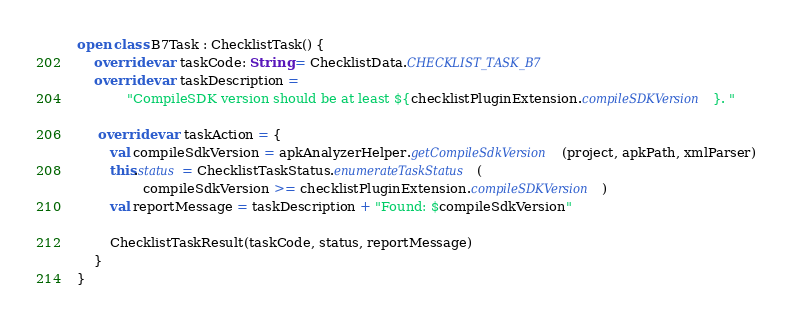Convert code to text. <code><loc_0><loc_0><loc_500><loc_500><_Kotlin_>open class B7Task : ChecklistTask() {
    override var taskCode: String = ChecklistData.CHECKLIST_TASK_B7
    override var taskDescription =
            "CompileSDK version should be at least ${checklistPluginExtension.compileSDKVersion}. "

     override var taskAction = {
        val compileSdkVersion = apkAnalyzerHelper.getCompileSdkVersion(project, apkPath, xmlParser)
        this.status = ChecklistTaskStatus.enumerateTaskStatus(
                compileSdkVersion >= checklistPluginExtension.compileSDKVersion)
        val reportMessage = taskDescription + "Found: $compileSdkVersion"

        ChecklistTaskResult(taskCode, status, reportMessage)
    }
}
</code> 